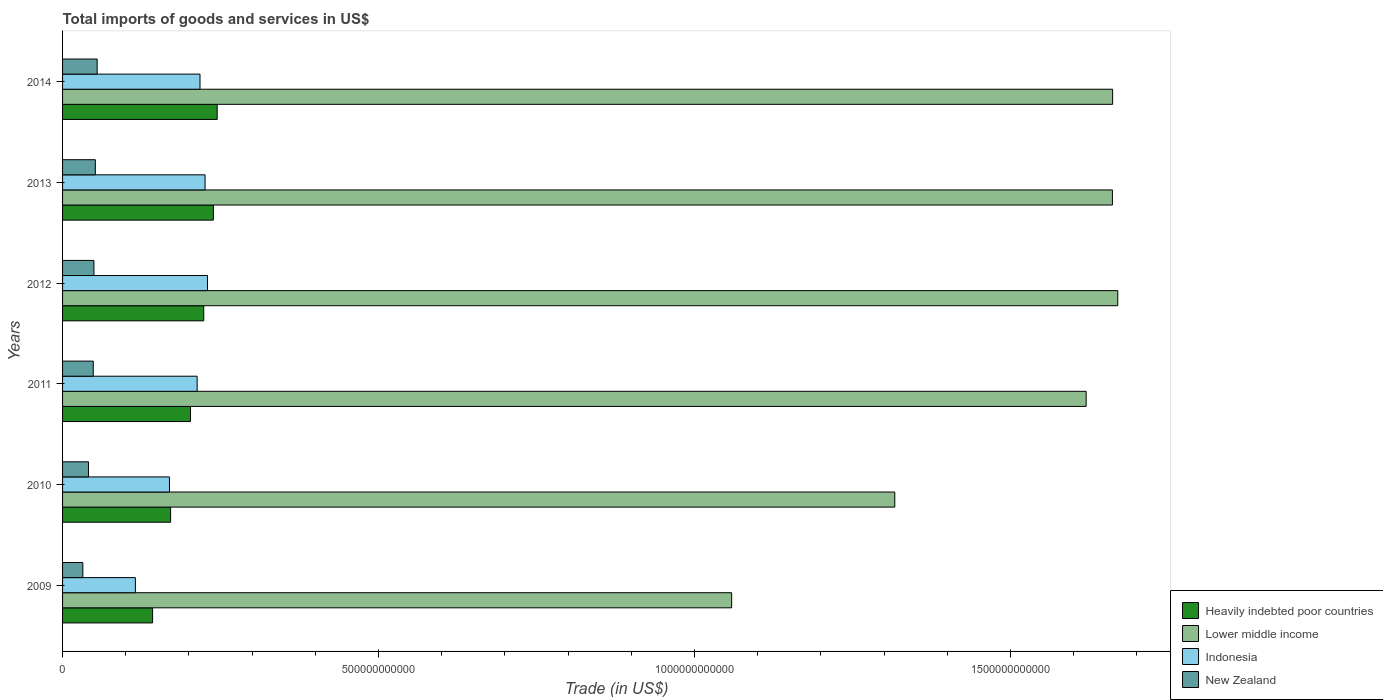How many different coloured bars are there?
Keep it short and to the point. 4. How many groups of bars are there?
Give a very brief answer. 6. How many bars are there on the 2nd tick from the top?
Ensure brevity in your answer.  4. How many bars are there on the 2nd tick from the bottom?
Your response must be concise. 4. What is the label of the 6th group of bars from the top?
Make the answer very short. 2009. In how many cases, is the number of bars for a given year not equal to the number of legend labels?
Make the answer very short. 0. What is the total imports of goods and services in Indonesia in 2014?
Give a very brief answer. 2.17e+11. Across all years, what is the maximum total imports of goods and services in Lower middle income?
Provide a short and direct response. 1.67e+12. Across all years, what is the minimum total imports of goods and services in New Zealand?
Keep it short and to the point. 3.21e+1. In which year was the total imports of goods and services in New Zealand maximum?
Offer a terse response. 2014. What is the total total imports of goods and services in Indonesia in the graph?
Your answer should be very brief. 1.17e+12. What is the difference between the total imports of goods and services in Indonesia in 2011 and that in 2013?
Your response must be concise. -1.25e+1. What is the difference between the total imports of goods and services in New Zealand in 2009 and the total imports of goods and services in Heavily indebted poor countries in 2012?
Keep it short and to the point. -1.91e+11. What is the average total imports of goods and services in Heavily indebted poor countries per year?
Keep it short and to the point. 2.04e+11. In the year 2014, what is the difference between the total imports of goods and services in Indonesia and total imports of goods and services in Heavily indebted poor countries?
Provide a short and direct response. -2.72e+1. In how many years, is the total imports of goods and services in Heavily indebted poor countries greater than 1400000000000 US$?
Give a very brief answer. 0. What is the ratio of the total imports of goods and services in Lower middle income in 2009 to that in 2011?
Offer a terse response. 0.65. Is the total imports of goods and services in Heavily indebted poor countries in 2010 less than that in 2011?
Offer a very short reply. Yes. Is the difference between the total imports of goods and services in Indonesia in 2012 and 2014 greater than the difference between the total imports of goods and services in Heavily indebted poor countries in 2012 and 2014?
Your answer should be very brief. Yes. What is the difference between the highest and the second highest total imports of goods and services in Lower middle income?
Offer a very short reply. 8.13e+09. What is the difference between the highest and the lowest total imports of goods and services in Heavily indebted poor countries?
Your answer should be compact. 1.02e+11. Is it the case that in every year, the sum of the total imports of goods and services in Heavily indebted poor countries and total imports of goods and services in Indonesia is greater than the sum of total imports of goods and services in Lower middle income and total imports of goods and services in New Zealand?
Your response must be concise. No. What does the 2nd bar from the top in 2013 represents?
Ensure brevity in your answer.  Indonesia. What does the 2nd bar from the bottom in 2011 represents?
Ensure brevity in your answer.  Lower middle income. Is it the case that in every year, the sum of the total imports of goods and services in Indonesia and total imports of goods and services in New Zealand is greater than the total imports of goods and services in Heavily indebted poor countries?
Ensure brevity in your answer.  Yes. How many bars are there?
Ensure brevity in your answer.  24. Are all the bars in the graph horizontal?
Make the answer very short. Yes. How many years are there in the graph?
Your answer should be compact. 6. What is the difference between two consecutive major ticks on the X-axis?
Your answer should be compact. 5.00e+11. Does the graph contain grids?
Give a very brief answer. No. Where does the legend appear in the graph?
Offer a terse response. Bottom right. How are the legend labels stacked?
Offer a terse response. Vertical. What is the title of the graph?
Offer a terse response. Total imports of goods and services in US$. What is the label or title of the X-axis?
Make the answer very short. Trade (in US$). What is the Trade (in US$) of Heavily indebted poor countries in 2009?
Your answer should be compact. 1.42e+11. What is the Trade (in US$) in Lower middle income in 2009?
Ensure brevity in your answer.  1.06e+12. What is the Trade (in US$) of Indonesia in 2009?
Offer a terse response. 1.15e+11. What is the Trade (in US$) of New Zealand in 2009?
Make the answer very short. 3.21e+1. What is the Trade (in US$) in Heavily indebted poor countries in 2010?
Your response must be concise. 1.71e+11. What is the Trade (in US$) in Lower middle income in 2010?
Offer a terse response. 1.32e+12. What is the Trade (in US$) of Indonesia in 2010?
Your answer should be very brief. 1.69e+11. What is the Trade (in US$) of New Zealand in 2010?
Ensure brevity in your answer.  4.10e+1. What is the Trade (in US$) in Heavily indebted poor countries in 2011?
Offer a very short reply. 2.02e+11. What is the Trade (in US$) of Lower middle income in 2011?
Ensure brevity in your answer.  1.62e+12. What is the Trade (in US$) of Indonesia in 2011?
Provide a succinct answer. 2.13e+11. What is the Trade (in US$) of New Zealand in 2011?
Provide a succinct answer. 4.85e+1. What is the Trade (in US$) of Heavily indebted poor countries in 2012?
Give a very brief answer. 2.23e+11. What is the Trade (in US$) in Lower middle income in 2012?
Ensure brevity in your answer.  1.67e+12. What is the Trade (in US$) in Indonesia in 2012?
Offer a very short reply. 2.29e+11. What is the Trade (in US$) of New Zealand in 2012?
Offer a terse response. 4.96e+1. What is the Trade (in US$) of Heavily indebted poor countries in 2013?
Give a very brief answer. 2.39e+11. What is the Trade (in US$) in Lower middle income in 2013?
Ensure brevity in your answer.  1.66e+12. What is the Trade (in US$) of Indonesia in 2013?
Provide a short and direct response. 2.26e+11. What is the Trade (in US$) of New Zealand in 2013?
Your response must be concise. 5.19e+1. What is the Trade (in US$) of Heavily indebted poor countries in 2014?
Ensure brevity in your answer.  2.45e+11. What is the Trade (in US$) of Lower middle income in 2014?
Offer a terse response. 1.66e+12. What is the Trade (in US$) in Indonesia in 2014?
Ensure brevity in your answer.  2.17e+11. What is the Trade (in US$) in New Zealand in 2014?
Your response must be concise. 5.47e+1. Across all years, what is the maximum Trade (in US$) in Heavily indebted poor countries?
Give a very brief answer. 2.45e+11. Across all years, what is the maximum Trade (in US$) of Lower middle income?
Offer a very short reply. 1.67e+12. Across all years, what is the maximum Trade (in US$) of Indonesia?
Offer a very short reply. 2.29e+11. Across all years, what is the maximum Trade (in US$) in New Zealand?
Your answer should be compact. 5.47e+1. Across all years, what is the minimum Trade (in US$) of Heavily indebted poor countries?
Offer a very short reply. 1.42e+11. Across all years, what is the minimum Trade (in US$) in Lower middle income?
Make the answer very short. 1.06e+12. Across all years, what is the minimum Trade (in US$) in Indonesia?
Offer a very short reply. 1.15e+11. Across all years, what is the minimum Trade (in US$) of New Zealand?
Your answer should be compact. 3.21e+1. What is the total Trade (in US$) in Heavily indebted poor countries in the graph?
Offer a terse response. 1.22e+12. What is the total Trade (in US$) of Lower middle income in the graph?
Offer a terse response. 8.99e+12. What is the total Trade (in US$) of Indonesia in the graph?
Keep it short and to the point. 1.17e+12. What is the total Trade (in US$) of New Zealand in the graph?
Your answer should be compact. 2.78e+11. What is the difference between the Trade (in US$) in Heavily indebted poor countries in 2009 and that in 2010?
Your response must be concise. -2.85e+1. What is the difference between the Trade (in US$) in Lower middle income in 2009 and that in 2010?
Your answer should be very brief. -2.58e+11. What is the difference between the Trade (in US$) in Indonesia in 2009 and that in 2010?
Make the answer very short. -5.39e+1. What is the difference between the Trade (in US$) of New Zealand in 2009 and that in 2010?
Make the answer very short. -8.94e+09. What is the difference between the Trade (in US$) in Heavily indebted poor countries in 2009 and that in 2011?
Your answer should be very brief. -6.00e+1. What is the difference between the Trade (in US$) in Lower middle income in 2009 and that in 2011?
Provide a short and direct response. -5.61e+11. What is the difference between the Trade (in US$) in Indonesia in 2009 and that in 2011?
Offer a very short reply. -9.78e+1. What is the difference between the Trade (in US$) of New Zealand in 2009 and that in 2011?
Keep it short and to the point. -1.65e+1. What is the difference between the Trade (in US$) in Heavily indebted poor countries in 2009 and that in 2012?
Offer a terse response. -8.10e+1. What is the difference between the Trade (in US$) of Lower middle income in 2009 and that in 2012?
Give a very brief answer. -6.11e+11. What is the difference between the Trade (in US$) of Indonesia in 2009 and that in 2012?
Give a very brief answer. -1.14e+11. What is the difference between the Trade (in US$) of New Zealand in 2009 and that in 2012?
Offer a very short reply. -1.76e+1. What is the difference between the Trade (in US$) in Heavily indebted poor countries in 2009 and that in 2013?
Offer a terse response. -9.62e+1. What is the difference between the Trade (in US$) of Lower middle income in 2009 and that in 2013?
Your response must be concise. -6.03e+11. What is the difference between the Trade (in US$) of Indonesia in 2009 and that in 2013?
Make the answer very short. -1.10e+11. What is the difference between the Trade (in US$) in New Zealand in 2009 and that in 2013?
Your answer should be compact. -1.98e+1. What is the difference between the Trade (in US$) in Heavily indebted poor countries in 2009 and that in 2014?
Your answer should be compact. -1.02e+11. What is the difference between the Trade (in US$) in Lower middle income in 2009 and that in 2014?
Keep it short and to the point. -6.03e+11. What is the difference between the Trade (in US$) of Indonesia in 2009 and that in 2014?
Give a very brief answer. -1.02e+11. What is the difference between the Trade (in US$) of New Zealand in 2009 and that in 2014?
Your answer should be very brief. -2.27e+1. What is the difference between the Trade (in US$) in Heavily indebted poor countries in 2010 and that in 2011?
Provide a succinct answer. -3.15e+1. What is the difference between the Trade (in US$) of Lower middle income in 2010 and that in 2011?
Your answer should be compact. -3.03e+11. What is the difference between the Trade (in US$) of Indonesia in 2010 and that in 2011?
Keep it short and to the point. -4.38e+1. What is the difference between the Trade (in US$) of New Zealand in 2010 and that in 2011?
Ensure brevity in your answer.  -7.55e+09. What is the difference between the Trade (in US$) in Heavily indebted poor countries in 2010 and that in 2012?
Keep it short and to the point. -5.25e+1. What is the difference between the Trade (in US$) in Lower middle income in 2010 and that in 2012?
Ensure brevity in your answer.  -3.53e+11. What is the difference between the Trade (in US$) in Indonesia in 2010 and that in 2012?
Your response must be concise. -6.02e+1. What is the difference between the Trade (in US$) in New Zealand in 2010 and that in 2012?
Keep it short and to the point. -8.62e+09. What is the difference between the Trade (in US$) in Heavily indebted poor countries in 2010 and that in 2013?
Keep it short and to the point. -6.77e+1. What is the difference between the Trade (in US$) in Lower middle income in 2010 and that in 2013?
Offer a very short reply. -3.44e+11. What is the difference between the Trade (in US$) in Indonesia in 2010 and that in 2013?
Give a very brief answer. -5.64e+1. What is the difference between the Trade (in US$) of New Zealand in 2010 and that in 2013?
Ensure brevity in your answer.  -1.09e+1. What is the difference between the Trade (in US$) of Heavily indebted poor countries in 2010 and that in 2014?
Your response must be concise. -7.37e+1. What is the difference between the Trade (in US$) of Lower middle income in 2010 and that in 2014?
Provide a succinct answer. -3.45e+11. What is the difference between the Trade (in US$) in Indonesia in 2010 and that in 2014?
Keep it short and to the point. -4.83e+1. What is the difference between the Trade (in US$) in New Zealand in 2010 and that in 2014?
Provide a succinct answer. -1.37e+1. What is the difference between the Trade (in US$) of Heavily indebted poor countries in 2011 and that in 2012?
Keep it short and to the point. -2.09e+1. What is the difference between the Trade (in US$) of Lower middle income in 2011 and that in 2012?
Provide a short and direct response. -5.00e+1. What is the difference between the Trade (in US$) in Indonesia in 2011 and that in 2012?
Give a very brief answer. -1.64e+1. What is the difference between the Trade (in US$) in New Zealand in 2011 and that in 2012?
Your answer should be compact. -1.07e+09. What is the difference between the Trade (in US$) of Heavily indebted poor countries in 2011 and that in 2013?
Your answer should be very brief. -3.62e+1. What is the difference between the Trade (in US$) of Lower middle income in 2011 and that in 2013?
Give a very brief answer. -4.15e+1. What is the difference between the Trade (in US$) in Indonesia in 2011 and that in 2013?
Your answer should be compact. -1.25e+1. What is the difference between the Trade (in US$) of New Zealand in 2011 and that in 2013?
Give a very brief answer. -3.30e+09. What is the difference between the Trade (in US$) in Heavily indebted poor countries in 2011 and that in 2014?
Provide a short and direct response. -4.22e+1. What is the difference between the Trade (in US$) in Lower middle income in 2011 and that in 2014?
Your answer should be very brief. -4.19e+1. What is the difference between the Trade (in US$) of Indonesia in 2011 and that in 2014?
Make the answer very short. -4.49e+09. What is the difference between the Trade (in US$) of New Zealand in 2011 and that in 2014?
Provide a succinct answer. -6.18e+09. What is the difference between the Trade (in US$) in Heavily indebted poor countries in 2012 and that in 2013?
Keep it short and to the point. -1.52e+1. What is the difference between the Trade (in US$) of Lower middle income in 2012 and that in 2013?
Your answer should be compact. 8.48e+09. What is the difference between the Trade (in US$) in Indonesia in 2012 and that in 2013?
Give a very brief answer. 3.84e+09. What is the difference between the Trade (in US$) in New Zealand in 2012 and that in 2013?
Your answer should be very brief. -2.24e+09. What is the difference between the Trade (in US$) in Heavily indebted poor countries in 2012 and that in 2014?
Provide a short and direct response. -2.12e+1. What is the difference between the Trade (in US$) of Lower middle income in 2012 and that in 2014?
Provide a short and direct response. 8.13e+09. What is the difference between the Trade (in US$) of Indonesia in 2012 and that in 2014?
Provide a short and direct response. 1.19e+1. What is the difference between the Trade (in US$) of New Zealand in 2012 and that in 2014?
Provide a short and direct response. -5.12e+09. What is the difference between the Trade (in US$) of Heavily indebted poor countries in 2013 and that in 2014?
Your answer should be compact. -6.01e+09. What is the difference between the Trade (in US$) in Lower middle income in 2013 and that in 2014?
Offer a very short reply. -3.50e+08. What is the difference between the Trade (in US$) in Indonesia in 2013 and that in 2014?
Offer a very short reply. 8.03e+09. What is the difference between the Trade (in US$) in New Zealand in 2013 and that in 2014?
Ensure brevity in your answer.  -2.88e+09. What is the difference between the Trade (in US$) in Heavily indebted poor countries in 2009 and the Trade (in US$) in Lower middle income in 2010?
Your answer should be very brief. -1.17e+12. What is the difference between the Trade (in US$) in Heavily indebted poor countries in 2009 and the Trade (in US$) in Indonesia in 2010?
Give a very brief answer. -2.67e+1. What is the difference between the Trade (in US$) in Heavily indebted poor countries in 2009 and the Trade (in US$) in New Zealand in 2010?
Provide a short and direct response. 1.01e+11. What is the difference between the Trade (in US$) of Lower middle income in 2009 and the Trade (in US$) of Indonesia in 2010?
Give a very brief answer. 8.90e+11. What is the difference between the Trade (in US$) of Lower middle income in 2009 and the Trade (in US$) of New Zealand in 2010?
Your response must be concise. 1.02e+12. What is the difference between the Trade (in US$) of Indonesia in 2009 and the Trade (in US$) of New Zealand in 2010?
Ensure brevity in your answer.  7.42e+1. What is the difference between the Trade (in US$) of Heavily indebted poor countries in 2009 and the Trade (in US$) of Lower middle income in 2011?
Your response must be concise. -1.48e+12. What is the difference between the Trade (in US$) of Heavily indebted poor countries in 2009 and the Trade (in US$) of Indonesia in 2011?
Offer a terse response. -7.05e+1. What is the difference between the Trade (in US$) in Heavily indebted poor countries in 2009 and the Trade (in US$) in New Zealand in 2011?
Offer a terse response. 9.39e+1. What is the difference between the Trade (in US$) of Lower middle income in 2009 and the Trade (in US$) of Indonesia in 2011?
Offer a terse response. 8.46e+11. What is the difference between the Trade (in US$) in Lower middle income in 2009 and the Trade (in US$) in New Zealand in 2011?
Your answer should be compact. 1.01e+12. What is the difference between the Trade (in US$) of Indonesia in 2009 and the Trade (in US$) of New Zealand in 2011?
Make the answer very short. 6.67e+1. What is the difference between the Trade (in US$) of Heavily indebted poor countries in 2009 and the Trade (in US$) of Lower middle income in 2012?
Provide a succinct answer. -1.53e+12. What is the difference between the Trade (in US$) in Heavily indebted poor countries in 2009 and the Trade (in US$) in Indonesia in 2012?
Provide a short and direct response. -8.69e+1. What is the difference between the Trade (in US$) of Heavily indebted poor countries in 2009 and the Trade (in US$) of New Zealand in 2012?
Your answer should be compact. 9.28e+1. What is the difference between the Trade (in US$) of Lower middle income in 2009 and the Trade (in US$) of Indonesia in 2012?
Keep it short and to the point. 8.29e+11. What is the difference between the Trade (in US$) in Lower middle income in 2009 and the Trade (in US$) in New Zealand in 2012?
Offer a terse response. 1.01e+12. What is the difference between the Trade (in US$) of Indonesia in 2009 and the Trade (in US$) of New Zealand in 2012?
Provide a succinct answer. 6.56e+1. What is the difference between the Trade (in US$) of Heavily indebted poor countries in 2009 and the Trade (in US$) of Lower middle income in 2013?
Offer a very short reply. -1.52e+12. What is the difference between the Trade (in US$) in Heavily indebted poor countries in 2009 and the Trade (in US$) in Indonesia in 2013?
Your response must be concise. -8.31e+1. What is the difference between the Trade (in US$) in Heavily indebted poor countries in 2009 and the Trade (in US$) in New Zealand in 2013?
Keep it short and to the point. 9.06e+1. What is the difference between the Trade (in US$) of Lower middle income in 2009 and the Trade (in US$) of Indonesia in 2013?
Give a very brief answer. 8.33e+11. What is the difference between the Trade (in US$) of Lower middle income in 2009 and the Trade (in US$) of New Zealand in 2013?
Provide a short and direct response. 1.01e+12. What is the difference between the Trade (in US$) in Indonesia in 2009 and the Trade (in US$) in New Zealand in 2013?
Make the answer very short. 6.34e+1. What is the difference between the Trade (in US$) in Heavily indebted poor countries in 2009 and the Trade (in US$) in Lower middle income in 2014?
Ensure brevity in your answer.  -1.52e+12. What is the difference between the Trade (in US$) of Heavily indebted poor countries in 2009 and the Trade (in US$) of Indonesia in 2014?
Offer a terse response. -7.50e+1. What is the difference between the Trade (in US$) of Heavily indebted poor countries in 2009 and the Trade (in US$) of New Zealand in 2014?
Provide a short and direct response. 8.77e+1. What is the difference between the Trade (in US$) of Lower middle income in 2009 and the Trade (in US$) of Indonesia in 2014?
Offer a very short reply. 8.41e+11. What is the difference between the Trade (in US$) of Lower middle income in 2009 and the Trade (in US$) of New Zealand in 2014?
Your answer should be very brief. 1.00e+12. What is the difference between the Trade (in US$) of Indonesia in 2009 and the Trade (in US$) of New Zealand in 2014?
Provide a succinct answer. 6.05e+1. What is the difference between the Trade (in US$) of Heavily indebted poor countries in 2010 and the Trade (in US$) of Lower middle income in 2011?
Ensure brevity in your answer.  -1.45e+12. What is the difference between the Trade (in US$) in Heavily indebted poor countries in 2010 and the Trade (in US$) in Indonesia in 2011?
Make the answer very short. -4.20e+1. What is the difference between the Trade (in US$) of Heavily indebted poor countries in 2010 and the Trade (in US$) of New Zealand in 2011?
Your response must be concise. 1.22e+11. What is the difference between the Trade (in US$) in Lower middle income in 2010 and the Trade (in US$) in Indonesia in 2011?
Offer a terse response. 1.10e+12. What is the difference between the Trade (in US$) of Lower middle income in 2010 and the Trade (in US$) of New Zealand in 2011?
Make the answer very short. 1.27e+12. What is the difference between the Trade (in US$) in Indonesia in 2010 and the Trade (in US$) in New Zealand in 2011?
Your response must be concise. 1.21e+11. What is the difference between the Trade (in US$) in Heavily indebted poor countries in 2010 and the Trade (in US$) in Lower middle income in 2012?
Your answer should be compact. -1.50e+12. What is the difference between the Trade (in US$) of Heavily indebted poor countries in 2010 and the Trade (in US$) of Indonesia in 2012?
Your answer should be very brief. -5.84e+1. What is the difference between the Trade (in US$) of Heavily indebted poor countries in 2010 and the Trade (in US$) of New Zealand in 2012?
Offer a very short reply. 1.21e+11. What is the difference between the Trade (in US$) of Lower middle income in 2010 and the Trade (in US$) of Indonesia in 2012?
Offer a terse response. 1.09e+12. What is the difference between the Trade (in US$) in Lower middle income in 2010 and the Trade (in US$) in New Zealand in 2012?
Ensure brevity in your answer.  1.27e+12. What is the difference between the Trade (in US$) of Indonesia in 2010 and the Trade (in US$) of New Zealand in 2012?
Give a very brief answer. 1.20e+11. What is the difference between the Trade (in US$) in Heavily indebted poor countries in 2010 and the Trade (in US$) in Lower middle income in 2013?
Keep it short and to the point. -1.49e+12. What is the difference between the Trade (in US$) of Heavily indebted poor countries in 2010 and the Trade (in US$) of Indonesia in 2013?
Your answer should be very brief. -5.46e+1. What is the difference between the Trade (in US$) in Heavily indebted poor countries in 2010 and the Trade (in US$) in New Zealand in 2013?
Your answer should be compact. 1.19e+11. What is the difference between the Trade (in US$) of Lower middle income in 2010 and the Trade (in US$) of Indonesia in 2013?
Your answer should be very brief. 1.09e+12. What is the difference between the Trade (in US$) in Lower middle income in 2010 and the Trade (in US$) in New Zealand in 2013?
Offer a very short reply. 1.27e+12. What is the difference between the Trade (in US$) in Indonesia in 2010 and the Trade (in US$) in New Zealand in 2013?
Your answer should be very brief. 1.17e+11. What is the difference between the Trade (in US$) in Heavily indebted poor countries in 2010 and the Trade (in US$) in Lower middle income in 2014?
Make the answer very short. -1.49e+12. What is the difference between the Trade (in US$) of Heavily indebted poor countries in 2010 and the Trade (in US$) of Indonesia in 2014?
Provide a short and direct response. -4.65e+1. What is the difference between the Trade (in US$) of Heavily indebted poor countries in 2010 and the Trade (in US$) of New Zealand in 2014?
Your response must be concise. 1.16e+11. What is the difference between the Trade (in US$) in Lower middle income in 2010 and the Trade (in US$) in Indonesia in 2014?
Your response must be concise. 1.10e+12. What is the difference between the Trade (in US$) of Lower middle income in 2010 and the Trade (in US$) of New Zealand in 2014?
Offer a very short reply. 1.26e+12. What is the difference between the Trade (in US$) in Indonesia in 2010 and the Trade (in US$) in New Zealand in 2014?
Offer a very short reply. 1.14e+11. What is the difference between the Trade (in US$) in Heavily indebted poor countries in 2011 and the Trade (in US$) in Lower middle income in 2012?
Provide a succinct answer. -1.47e+12. What is the difference between the Trade (in US$) of Heavily indebted poor countries in 2011 and the Trade (in US$) of Indonesia in 2012?
Your answer should be very brief. -2.69e+1. What is the difference between the Trade (in US$) in Heavily indebted poor countries in 2011 and the Trade (in US$) in New Zealand in 2012?
Offer a very short reply. 1.53e+11. What is the difference between the Trade (in US$) of Lower middle income in 2011 and the Trade (in US$) of Indonesia in 2012?
Provide a succinct answer. 1.39e+12. What is the difference between the Trade (in US$) of Lower middle income in 2011 and the Trade (in US$) of New Zealand in 2012?
Your answer should be very brief. 1.57e+12. What is the difference between the Trade (in US$) of Indonesia in 2011 and the Trade (in US$) of New Zealand in 2012?
Provide a succinct answer. 1.63e+11. What is the difference between the Trade (in US$) in Heavily indebted poor countries in 2011 and the Trade (in US$) in Lower middle income in 2013?
Provide a succinct answer. -1.46e+12. What is the difference between the Trade (in US$) in Heavily indebted poor countries in 2011 and the Trade (in US$) in Indonesia in 2013?
Give a very brief answer. -2.30e+1. What is the difference between the Trade (in US$) in Heavily indebted poor countries in 2011 and the Trade (in US$) in New Zealand in 2013?
Keep it short and to the point. 1.51e+11. What is the difference between the Trade (in US$) in Lower middle income in 2011 and the Trade (in US$) in Indonesia in 2013?
Make the answer very short. 1.39e+12. What is the difference between the Trade (in US$) in Lower middle income in 2011 and the Trade (in US$) in New Zealand in 2013?
Offer a very short reply. 1.57e+12. What is the difference between the Trade (in US$) of Indonesia in 2011 and the Trade (in US$) of New Zealand in 2013?
Provide a succinct answer. 1.61e+11. What is the difference between the Trade (in US$) in Heavily indebted poor countries in 2011 and the Trade (in US$) in Lower middle income in 2014?
Offer a very short reply. -1.46e+12. What is the difference between the Trade (in US$) of Heavily indebted poor countries in 2011 and the Trade (in US$) of Indonesia in 2014?
Ensure brevity in your answer.  -1.50e+1. What is the difference between the Trade (in US$) in Heavily indebted poor countries in 2011 and the Trade (in US$) in New Zealand in 2014?
Your response must be concise. 1.48e+11. What is the difference between the Trade (in US$) in Lower middle income in 2011 and the Trade (in US$) in Indonesia in 2014?
Offer a very short reply. 1.40e+12. What is the difference between the Trade (in US$) in Lower middle income in 2011 and the Trade (in US$) in New Zealand in 2014?
Your response must be concise. 1.57e+12. What is the difference between the Trade (in US$) in Indonesia in 2011 and the Trade (in US$) in New Zealand in 2014?
Ensure brevity in your answer.  1.58e+11. What is the difference between the Trade (in US$) in Heavily indebted poor countries in 2012 and the Trade (in US$) in Lower middle income in 2013?
Your answer should be compact. -1.44e+12. What is the difference between the Trade (in US$) in Heavily indebted poor countries in 2012 and the Trade (in US$) in Indonesia in 2013?
Your response must be concise. -2.09e+09. What is the difference between the Trade (in US$) of Heavily indebted poor countries in 2012 and the Trade (in US$) of New Zealand in 2013?
Make the answer very short. 1.72e+11. What is the difference between the Trade (in US$) of Lower middle income in 2012 and the Trade (in US$) of Indonesia in 2013?
Your answer should be compact. 1.44e+12. What is the difference between the Trade (in US$) of Lower middle income in 2012 and the Trade (in US$) of New Zealand in 2013?
Keep it short and to the point. 1.62e+12. What is the difference between the Trade (in US$) of Indonesia in 2012 and the Trade (in US$) of New Zealand in 2013?
Offer a terse response. 1.78e+11. What is the difference between the Trade (in US$) in Heavily indebted poor countries in 2012 and the Trade (in US$) in Lower middle income in 2014?
Offer a very short reply. -1.44e+12. What is the difference between the Trade (in US$) of Heavily indebted poor countries in 2012 and the Trade (in US$) of Indonesia in 2014?
Your answer should be very brief. 5.94e+09. What is the difference between the Trade (in US$) of Heavily indebted poor countries in 2012 and the Trade (in US$) of New Zealand in 2014?
Your answer should be compact. 1.69e+11. What is the difference between the Trade (in US$) in Lower middle income in 2012 and the Trade (in US$) in Indonesia in 2014?
Offer a terse response. 1.45e+12. What is the difference between the Trade (in US$) of Lower middle income in 2012 and the Trade (in US$) of New Zealand in 2014?
Keep it short and to the point. 1.62e+12. What is the difference between the Trade (in US$) in Indonesia in 2012 and the Trade (in US$) in New Zealand in 2014?
Give a very brief answer. 1.75e+11. What is the difference between the Trade (in US$) in Heavily indebted poor countries in 2013 and the Trade (in US$) in Lower middle income in 2014?
Keep it short and to the point. -1.42e+12. What is the difference between the Trade (in US$) in Heavily indebted poor countries in 2013 and the Trade (in US$) in Indonesia in 2014?
Make the answer very short. 2.12e+1. What is the difference between the Trade (in US$) of Heavily indebted poor countries in 2013 and the Trade (in US$) of New Zealand in 2014?
Your answer should be very brief. 1.84e+11. What is the difference between the Trade (in US$) of Lower middle income in 2013 and the Trade (in US$) of Indonesia in 2014?
Ensure brevity in your answer.  1.44e+12. What is the difference between the Trade (in US$) of Lower middle income in 2013 and the Trade (in US$) of New Zealand in 2014?
Provide a short and direct response. 1.61e+12. What is the difference between the Trade (in US$) of Indonesia in 2013 and the Trade (in US$) of New Zealand in 2014?
Provide a succinct answer. 1.71e+11. What is the average Trade (in US$) in Heavily indebted poor countries per year?
Your response must be concise. 2.04e+11. What is the average Trade (in US$) of Lower middle income per year?
Offer a terse response. 1.50e+12. What is the average Trade (in US$) of Indonesia per year?
Offer a very short reply. 1.95e+11. What is the average Trade (in US$) of New Zealand per year?
Your answer should be very brief. 4.63e+1. In the year 2009, what is the difference between the Trade (in US$) of Heavily indebted poor countries and Trade (in US$) of Lower middle income?
Offer a terse response. -9.16e+11. In the year 2009, what is the difference between the Trade (in US$) in Heavily indebted poor countries and Trade (in US$) in Indonesia?
Ensure brevity in your answer.  2.72e+1. In the year 2009, what is the difference between the Trade (in US$) in Heavily indebted poor countries and Trade (in US$) in New Zealand?
Make the answer very short. 1.10e+11. In the year 2009, what is the difference between the Trade (in US$) of Lower middle income and Trade (in US$) of Indonesia?
Provide a short and direct response. 9.44e+11. In the year 2009, what is the difference between the Trade (in US$) of Lower middle income and Trade (in US$) of New Zealand?
Your response must be concise. 1.03e+12. In the year 2009, what is the difference between the Trade (in US$) of Indonesia and Trade (in US$) of New Zealand?
Offer a very short reply. 8.32e+1. In the year 2010, what is the difference between the Trade (in US$) of Heavily indebted poor countries and Trade (in US$) of Lower middle income?
Offer a terse response. -1.15e+12. In the year 2010, what is the difference between the Trade (in US$) in Heavily indebted poor countries and Trade (in US$) in Indonesia?
Give a very brief answer. 1.81e+09. In the year 2010, what is the difference between the Trade (in US$) of Heavily indebted poor countries and Trade (in US$) of New Zealand?
Provide a short and direct response. 1.30e+11. In the year 2010, what is the difference between the Trade (in US$) in Lower middle income and Trade (in US$) in Indonesia?
Provide a short and direct response. 1.15e+12. In the year 2010, what is the difference between the Trade (in US$) of Lower middle income and Trade (in US$) of New Zealand?
Ensure brevity in your answer.  1.28e+12. In the year 2010, what is the difference between the Trade (in US$) in Indonesia and Trade (in US$) in New Zealand?
Your answer should be very brief. 1.28e+11. In the year 2011, what is the difference between the Trade (in US$) in Heavily indebted poor countries and Trade (in US$) in Lower middle income?
Give a very brief answer. -1.42e+12. In the year 2011, what is the difference between the Trade (in US$) of Heavily indebted poor countries and Trade (in US$) of Indonesia?
Provide a short and direct response. -1.05e+1. In the year 2011, what is the difference between the Trade (in US$) of Heavily indebted poor countries and Trade (in US$) of New Zealand?
Ensure brevity in your answer.  1.54e+11. In the year 2011, what is the difference between the Trade (in US$) of Lower middle income and Trade (in US$) of Indonesia?
Keep it short and to the point. 1.41e+12. In the year 2011, what is the difference between the Trade (in US$) in Lower middle income and Trade (in US$) in New Zealand?
Keep it short and to the point. 1.57e+12. In the year 2011, what is the difference between the Trade (in US$) of Indonesia and Trade (in US$) of New Zealand?
Offer a terse response. 1.64e+11. In the year 2012, what is the difference between the Trade (in US$) of Heavily indebted poor countries and Trade (in US$) of Lower middle income?
Keep it short and to the point. -1.45e+12. In the year 2012, what is the difference between the Trade (in US$) of Heavily indebted poor countries and Trade (in US$) of Indonesia?
Offer a very short reply. -5.93e+09. In the year 2012, what is the difference between the Trade (in US$) in Heavily indebted poor countries and Trade (in US$) in New Zealand?
Make the answer very short. 1.74e+11. In the year 2012, what is the difference between the Trade (in US$) in Lower middle income and Trade (in US$) in Indonesia?
Give a very brief answer. 1.44e+12. In the year 2012, what is the difference between the Trade (in US$) in Lower middle income and Trade (in US$) in New Zealand?
Offer a very short reply. 1.62e+12. In the year 2012, what is the difference between the Trade (in US$) of Indonesia and Trade (in US$) of New Zealand?
Your response must be concise. 1.80e+11. In the year 2013, what is the difference between the Trade (in US$) in Heavily indebted poor countries and Trade (in US$) in Lower middle income?
Offer a very short reply. -1.42e+12. In the year 2013, what is the difference between the Trade (in US$) of Heavily indebted poor countries and Trade (in US$) of Indonesia?
Ensure brevity in your answer.  1.31e+1. In the year 2013, what is the difference between the Trade (in US$) in Heavily indebted poor countries and Trade (in US$) in New Zealand?
Your answer should be compact. 1.87e+11. In the year 2013, what is the difference between the Trade (in US$) of Lower middle income and Trade (in US$) of Indonesia?
Provide a short and direct response. 1.44e+12. In the year 2013, what is the difference between the Trade (in US$) of Lower middle income and Trade (in US$) of New Zealand?
Make the answer very short. 1.61e+12. In the year 2013, what is the difference between the Trade (in US$) in Indonesia and Trade (in US$) in New Zealand?
Keep it short and to the point. 1.74e+11. In the year 2014, what is the difference between the Trade (in US$) of Heavily indebted poor countries and Trade (in US$) of Lower middle income?
Your answer should be compact. -1.42e+12. In the year 2014, what is the difference between the Trade (in US$) of Heavily indebted poor countries and Trade (in US$) of Indonesia?
Your response must be concise. 2.72e+1. In the year 2014, what is the difference between the Trade (in US$) of Heavily indebted poor countries and Trade (in US$) of New Zealand?
Keep it short and to the point. 1.90e+11. In the year 2014, what is the difference between the Trade (in US$) of Lower middle income and Trade (in US$) of Indonesia?
Offer a very short reply. 1.44e+12. In the year 2014, what is the difference between the Trade (in US$) of Lower middle income and Trade (in US$) of New Zealand?
Provide a succinct answer. 1.61e+12. In the year 2014, what is the difference between the Trade (in US$) in Indonesia and Trade (in US$) in New Zealand?
Provide a short and direct response. 1.63e+11. What is the ratio of the Trade (in US$) in Heavily indebted poor countries in 2009 to that in 2010?
Provide a short and direct response. 0.83. What is the ratio of the Trade (in US$) of Lower middle income in 2009 to that in 2010?
Offer a very short reply. 0.8. What is the ratio of the Trade (in US$) in Indonesia in 2009 to that in 2010?
Your answer should be very brief. 0.68. What is the ratio of the Trade (in US$) in New Zealand in 2009 to that in 2010?
Your answer should be very brief. 0.78. What is the ratio of the Trade (in US$) in Heavily indebted poor countries in 2009 to that in 2011?
Provide a short and direct response. 0.7. What is the ratio of the Trade (in US$) of Lower middle income in 2009 to that in 2011?
Your answer should be compact. 0.65. What is the ratio of the Trade (in US$) in Indonesia in 2009 to that in 2011?
Provide a short and direct response. 0.54. What is the ratio of the Trade (in US$) of New Zealand in 2009 to that in 2011?
Make the answer very short. 0.66. What is the ratio of the Trade (in US$) of Heavily indebted poor countries in 2009 to that in 2012?
Your answer should be very brief. 0.64. What is the ratio of the Trade (in US$) of Lower middle income in 2009 to that in 2012?
Your answer should be compact. 0.63. What is the ratio of the Trade (in US$) of Indonesia in 2009 to that in 2012?
Provide a succinct answer. 0.5. What is the ratio of the Trade (in US$) in New Zealand in 2009 to that in 2012?
Ensure brevity in your answer.  0.65. What is the ratio of the Trade (in US$) in Heavily indebted poor countries in 2009 to that in 2013?
Provide a succinct answer. 0.6. What is the ratio of the Trade (in US$) in Lower middle income in 2009 to that in 2013?
Offer a terse response. 0.64. What is the ratio of the Trade (in US$) of Indonesia in 2009 to that in 2013?
Offer a terse response. 0.51. What is the ratio of the Trade (in US$) in New Zealand in 2009 to that in 2013?
Give a very brief answer. 0.62. What is the ratio of the Trade (in US$) of Heavily indebted poor countries in 2009 to that in 2014?
Your answer should be very brief. 0.58. What is the ratio of the Trade (in US$) of Lower middle income in 2009 to that in 2014?
Provide a succinct answer. 0.64. What is the ratio of the Trade (in US$) in Indonesia in 2009 to that in 2014?
Make the answer very short. 0.53. What is the ratio of the Trade (in US$) in New Zealand in 2009 to that in 2014?
Ensure brevity in your answer.  0.59. What is the ratio of the Trade (in US$) in Heavily indebted poor countries in 2010 to that in 2011?
Offer a very short reply. 0.84. What is the ratio of the Trade (in US$) of Lower middle income in 2010 to that in 2011?
Your response must be concise. 0.81. What is the ratio of the Trade (in US$) of Indonesia in 2010 to that in 2011?
Give a very brief answer. 0.79. What is the ratio of the Trade (in US$) of New Zealand in 2010 to that in 2011?
Keep it short and to the point. 0.84. What is the ratio of the Trade (in US$) in Heavily indebted poor countries in 2010 to that in 2012?
Give a very brief answer. 0.77. What is the ratio of the Trade (in US$) of Lower middle income in 2010 to that in 2012?
Make the answer very short. 0.79. What is the ratio of the Trade (in US$) of Indonesia in 2010 to that in 2012?
Your answer should be very brief. 0.74. What is the ratio of the Trade (in US$) in New Zealand in 2010 to that in 2012?
Provide a succinct answer. 0.83. What is the ratio of the Trade (in US$) in Heavily indebted poor countries in 2010 to that in 2013?
Keep it short and to the point. 0.72. What is the ratio of the Trade (in US$) of Lower middle income in 2010 to that in 2013?
Make the answer very short. 0.79. What is the ratio of the Trade (in US$) in Indonesia in 2010 to that in 2013?
Your answer should be very brief. 0.75. What is the ratio of the Trade (in US$) in New Zealand in 2010 to that in 2013?
Give a very brief answer. 0.79. What is the ratio of the Trade (in US$) of Heavily indebted poor countries in 2010 to that in 2014?
Offer a terse response. 0.7. What is the ratio of the Trade (in US$) of Lower middle income in 2010 to that in 2014?
Your answer should be very brief. 0.79. What is the ratio of the Trade (in US$) in New Zealand in 2010 to that in 2014?
Provide a succinct answer. 0.75. What is the ratio of the Trade (in US$) in Heavily indebted poor countries in 2011 to that in 2012?
Offer a very short reply. 0.91. What is the ratio of the Trade (in US$) in New Zealand in 2011 to that in 2012?
Offer a very short reply. 0.98. What is the ratio of the Trade (in US$) of Heavily indebted poor countries in 2011 to that in 2013?
Give a very brief answer. 0.85. What is the ratio of the Trade (in US$) of Lower middle income in 2011 to that in 2013?
Keep it short and to the point. 0.97. What is the ratio of the Trade (in US$) of Indonesia in 2011 to that in 2013?
Offer a terse response. 0.94. What is the ratio of the Trade (in US$) of New Zealand in 2011 to that in 2013?
Give a very brief answer. 0.94. What is the ratio of the Trade (in US$) in Heavily indebted poor countries in 2011 to that in 2014?
Make the answer very short. 0.83. What is the ratio of the Trade (in US$) in Lower middle income in 2011 to that in 2014?
Provide a succinct answer. 0.97. What is the ratio of the Trade (in US$) of Indonesia in 2011 to that in 2014?
Provide a short and direct response. 0.98. What is the ratio of the Trade (in US$) in New Zealand in 2011 to that in 2014?
Your answer should be compact. 0.89. What is the ratio of the Trade (in US$) of Heavily indebted poor countries in 2012 to that in 2013?
Make the answer very short. 0.94. What is the ratio of the Trade (in US$) of New Zealand in 2012 to that in 2013?
Provide a short and direct response. 0.96. What is the ratio of the Trade (in US$) of Heavily indebted poor countries in 2012 to that in 2014?
Offer a terse response. 0.91. What is the ratio of the Trade (in US$) of Lower middle income in 2012 to that in 2014?
Offer a very short reply. 1. What is the ratio of the Trade (in US$) in Indonesia in 2012 to that in 2014?
Keep it short and to the point. 1.05. What is the ratio of the Trade (in US$) in New Zealand in 2012 to that in 2014?
Keep it short and to the point. 0.91. What is the ratio of the Trade (in US$) of Heavily indebted poor countries in 2013 to that in 2014?
Keep it short and to the point. 0.98. What is the ratio of the Trade (in US$) of Indonesia in 2013 to that in 2014?
Keep it short and to the point. 1.04. What is the ratio of the Trade (in US$) of New Zealand in 2013 to that in 2014?
Ensure brevity in your answer.  0.95. What is the difference between the highest and the second highest Trade (in US$) of Heavily indebted poor countries?
Your response must be concise. 6.01e+09. What is the difference between the highest and the second highest Trade (in US$) in Lower middle income?
Your answer should be compact. 8.13e+09. What is the difference between the highest and the second highest Trade (in US$) of Indonesia?
Provide a succinct answer. 3.84e+09. What is the difference between the highest and the second highest Trade (in US$) of New Zealand?
Offer a terse response. 2.88e+09. What is the difference between the highest and the lowest Trade (in US$) of Heavily indebted poor countries?
Provide a succinct answer. 1.02e+11. What is the difference between the highest and the lowest Trade (in US$) in Lower middle income?
Your answer should be very brief. 6.11e+11. What is the difference between the highest and the lowest Trade (in US$) in Indonesia?
Offer a terse response. 1.14e+11. What is the difference between the highest and the lowest Trade (in US$) of New Zealand?
Your response must be concise. 2.27e+1. 